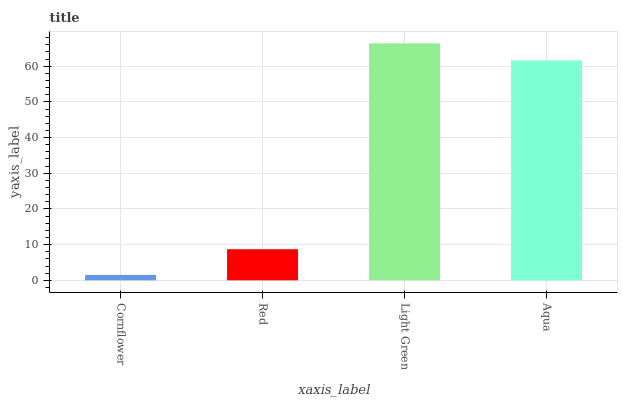Is Cornflower the minimum?
Answer yes or no. Yes. Is Light Green the maximum?
Answer yes or no. Yes. Is Red the minimum?
Answer yes or no. No. Is Red the maximum?
Answer yes or no. No. Is Red greater than Cornflower?
Answer yes or no. Yes. Is Cornflower less than Red?
Answer yes or no. Yes. Is Cornflower greater than Red?
Answer yes or no. No. Is Red less than Cornflower?
Answer yes or no. No. Is Aqua the high median?
Answer yes or no. Yes. Is Red the low median?
Answer yes or no. Yes. Is Light Green the high median?
Answer yes or no. No. Is Light Green the low median?
Answer yes or no. No. 